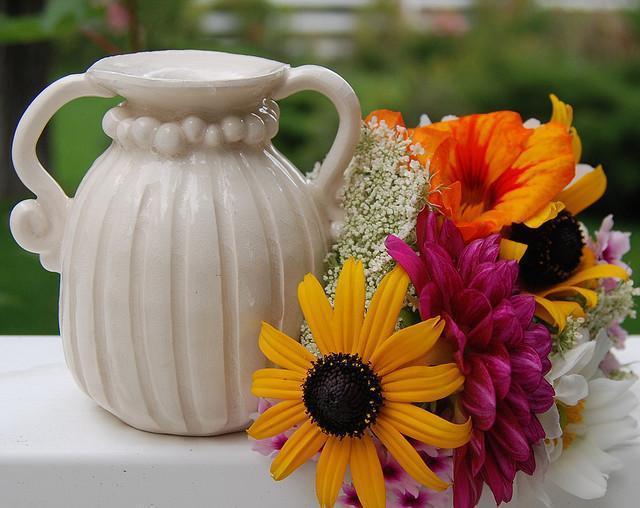How many pink flowers are shown?
Give a very brief answer. 1. How many knives are in the photo?
Give a very brief answer. 0. 